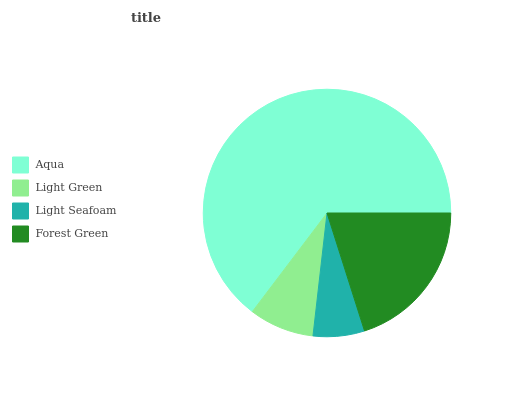Is Light Seafoam the minimum?
Answer yes or no. Yes. Is Aqua the maximum?
Answer yes or no. Yes. Is Light Green the minimum?
Answer yes or no. No. Is Light Green the maximum?
Answer yes or no. No. Is Aqua greater than Light Green?
Answer yes or no. Yes. Is Light Green less than Aqua?
Answer yes or no. Yes. Is Light Green greater than Aqua?
Answer yes or no. No. Is Aqua less than Light Green?
Answer yes or no. No. Is Forest Green the high median?
Answer yes or no. Yes. Is Light Green the low median?
Answer yes or no. Yes. Is Aqua the high median?
Answer yes or no. No. Is Light Seafoam the low median?
Answer yes or no. No. 